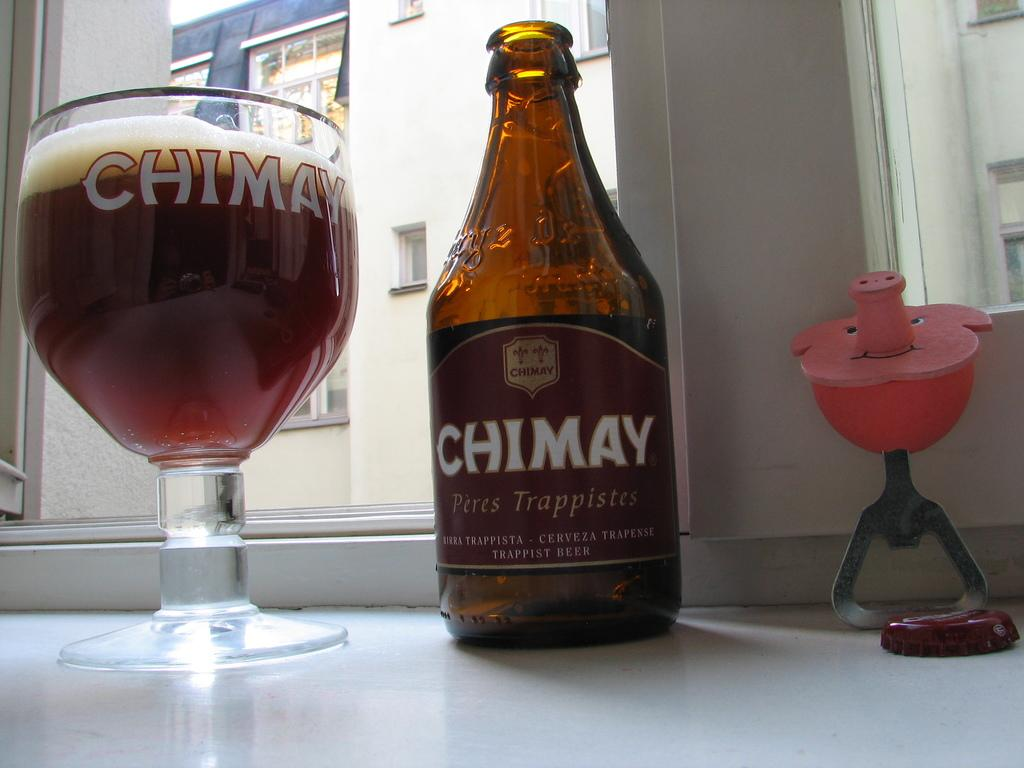<image>
Provide a brief description of the given image. A bottle of CHIMAY Peres Trappistes is sitting on the table. 